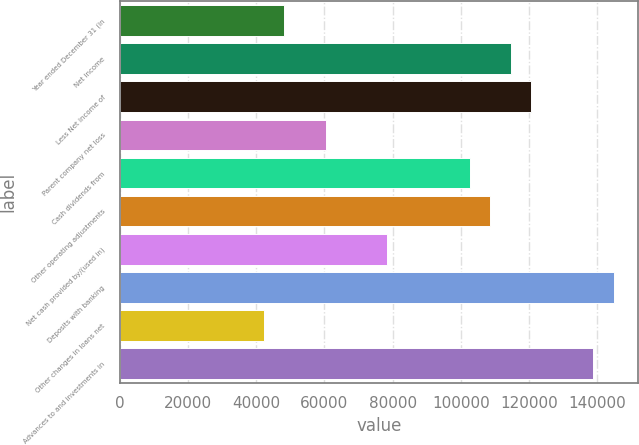Convert chart. <chart><loc_0><loc_0><loc_500><loc_500><bar_chart><fcel>Year ended December 31 (in<fcel>Net income<fcel>Less Net income of<fcel>Parent company net loss<fcel>Cash dividends from<fcel>Other operating adjustments<fcel>Net cash provided by/(used in)<fcel>Deposits with banking<fcel>Other changes in loans net<fcel>Advances to and investments in<nl><fcel>48287<fcel>114628<fcel>120659<fcel>60349<fcel>102566<fcel>108597<fcel>78442<fcel>144783<fcel>42256<fcel>138752<nl></chart> 